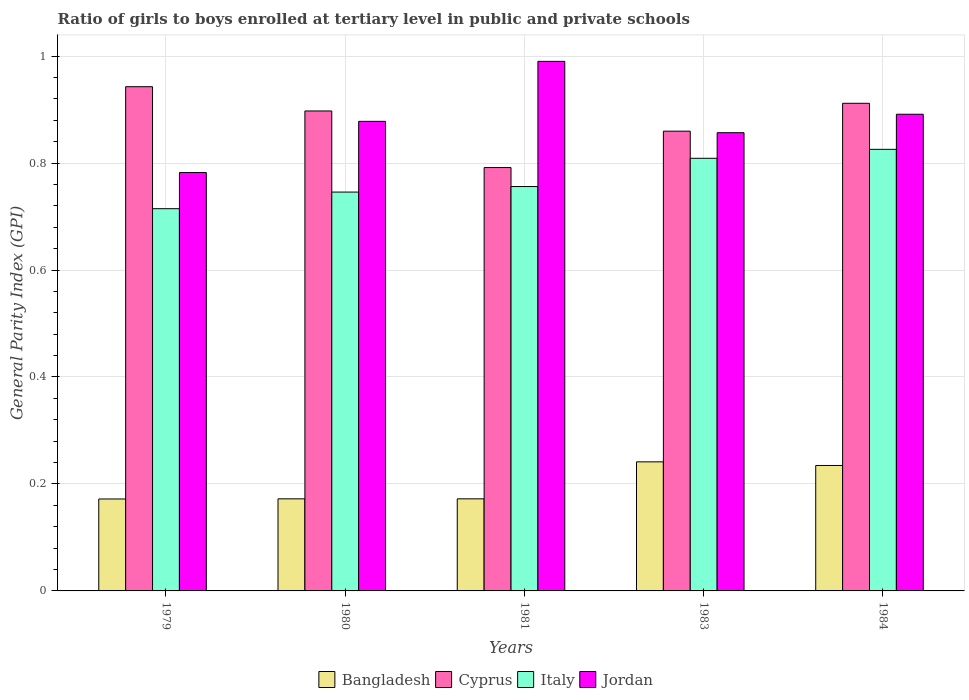Are the number of bars per tick equal to the number of legend labels?
Make the answer very short. Yes. Are the number of bars on each tick of the X-axis equal?
Provide a succinct answer. Yes. How many bars are there on the 5th tick from the left?
Provide a succinct answer. 4. How many bars are there on the 3rd tick from the right?
Your answer should be compact. 4. What is the label of the 2nd group of bars from the left?
Keep it short and to the point. 1980. In how many cases, is the number of bars for a given year not equal to the number of legend labels?
Ensure brevity in your answer.  0. What is the general parity index in Bangladesh in 1983?
Offer a very short reply. 0.24. Across all years, what is the minimum general parity index in Italy?
Provide a succinct answer. 0.71. In which year was the general parity index in Cyprus maximum?
Keep it short and to the point. 1979. What is the total general parity index in Bangladesh in the graph?
Provide a short and direct response. 0.99. What is the difference between the general parity index in Cyprus in 1981 and that in 1983?
Your answer should be compact. -0.07. What is the difference between the general parity index in Italy in 1981 and the general parity index in Jordan in 1983?
Your answer should be very brief. -0.1. What is the average general parity index in Italy per year?
Make the answer very short. 0.77. In the year 1983, what is the difference between the general parity index in Cyprus and general parity index in Bangladesh?
Make the answer very short. 0.62. What is the ratio of the general parity index in Italy in 1979 to that in 1980?
Your answer should be very brief. 0.96. What is the difference between the highest and the second highest general parity index in Jordan?
Make the answer very short. 0.1. What is the difference between the highest and the lowest general parity index in Italy?
Your response must be concise. 0.11. In how many years, is the general parity index in Cyprus greater than the average general parity index in Cyprus taken over all years?
Ensure brevity in your answer.  3. Is the sum of the general parity index in Cyprus in 1980 and 1981 greater than the maximum general parity index in Italy across all years?
Your answer should be compact. Yes. What does the 2nd bar from the left in 1981 represents?
Your answer should be very brief. Cyprus. What does the 1st bar from the right in 1980 represents?
Ensure brevity in your answer.  Jordan. Is it the case that in every year, the sum of the general parity index in Italy and general parity index in Cyprus is greater than the general parity index in Bangladesh?
Provide a short and direct response. Yes. Are all the bars in the graph horizontal?
Your answer should be compact. No. How many years are there in the graph?
Offer a very short reply. 5. Does the graph contain any zero values?
Offer a terse response. No. How many legend labels are there?
Give a very brief answer. 4. How are the legend labels stacked?
Your response must be concise. Horizontal. What is the title of the graph?
Your answer should be compact. Ratio of girls to boys enrolled at tertiary level in public and private schools. What is the label or title of the X-axis?
Ensure brevity in your answer.  Years. What is the label or title of the Y-axis?
Make the answer very short. General Parity Index (GPI). What is the General Parity Index (GPI) of Bangladesh in 1979?
Make the answer very short. 0.17. What is the General Parity Index (GPI) in Cyprus in 1979?
Keep it short and to the point. 0.94. What is the General Parity Index (GPI) of Italy in 1979?
Provide a short and direct response. 0.71. What is the General Parity Index (GPI) of Jordan in 1979?
Offer a very short reply. 0.78. What is the General Parity Index (GPI) of Bangladesh in 1980?
Your answer should be compact. 0.17. What is the General Parity Index (GPI) in Cyprus in 1980?
Offer a very short reply. 0.9. What is the General Parity Index (GPI) in Italy in 1980?
Your answer should be very brief. 0.75. What is the General Parity Index (GPI) in Jordan in 1980?
Offer a very short reply. 0.88. What is the General Parity Index (GPI) in Bangladesh in 1981?
Your answer should be very brief. 0.17. What is the General Parity Index (GPI) in Cyprus in 1981?
Make the answer very short. 0.79. What is the General Parity Index (GPI) of Italy in 1981?
Provide a succinct answer. 0.76. What is the General Parity Index (GPI) of Bangladesh in 1983?
Keep it short and to the point. 0.24. What is the General Parity Index (GPI) of Cyprus in 1983?
Offer a very short reply. 0.86. What is the General Parity Index (GPI) of Italy in 1983?
Give a very brief answer. 0.81. What is the General Parity Index (GPI) in Jordan in 1983?
Ensure brevity in your answer.  0.86. What is the General Parity Index (GPI) of Bangladesh in 1984?
Your answer should be compact. 0.23. What is the General Parity Index (GPI) in Cyprus in 1984?
Your answer should be very brief. 0.91. What is the General Parity Index (GPI) in Italy in 1984?
Ensure brevity in your answer.  0.83. What is the General Parity Index (GPI) of Jordan in 1984?
Give a very brief answer. 0.89. Across all years, what is the maximum General Parity Index (GPI) in Bangladesh?
Make the answer very short. 0.24. Across all years, what is the maximum General Parity Index (GPI) of Cyprus?
Make the answer very short. 0.94. Across all years, what is the maximum General Parity Index (GPI) of Italy?
Keep it short and to the point. 0.83. Across all years, what is the maximum General Parity Index (GPI) of Jordan?
Your response must be concise. 0.99. Across all years, what is the minimum General Parity Index (GPI) of Bangladesh?
Give a very brief answer. 0.17. Across all years, what is the minimum General Parity Index (GPI) in Cyprus?
Give a very brief answer. 0.79. Across all years, what is the minimum General Parity Index (GPI) of Italy?
Your answer should be very brief. 0.71. Across all years, what is the minimum General Parity Index (GPI) in Jordan?
Your answer should be very brief. 0.78. What is the total General Parity Index (GPI) of Bangladesh in the graph?
Make the answer very short. 0.99. What is the total General Parity Index (GPI) in Cyprus in the graph?
Ensure brevity in your answer.  4.4. What is the total General Parity Index (GPI) in Italy in the graph?
Provide a short and direct response. 3.85. What is the total General Parity Index (GPI) of Jordan in the graph?
Make the answer very short. 4.4. What is the difference between the General Parity Index (GPI) of Bangladesh in 1979 and that in 1980?
Offer a terse response. -0. What is the difference between the General Parity Index (GPI) in Cyprus in 1979 and that in 1980?
Your response must be concise. 0.05. What is the difference between the General Parity Index (GPI) in Italy in 1979 and that in 1980?
Your answer should be very brief. -0.03. What is the difference between the General Parity Index (GPI) of Jordan in 1979 and that in 1980?
Provide a short and direct response. -0.1. What is the difference between the General Parity Index (GPI) of Bangladesh in 1979 and that in 1981?
Offer a terse response. -0. What is the difference between the General Parity Index (GPI) in Cyprus in 1979 and that in 1981?
Ensure brevity in your answer.  0.15. What is the difference between the General Parity Index (GPI) in Italy in 1979 and that in 1981?
Give a very brief answer. -0.04. What is the difference between the General Parity Index (GPI) of Jordan in 1979 and that in 1981?
Offer a very short reply. -0.21. What is the difference between the General Parity Index (GPI) of Bangladesh in 1979 and that in 1983?
Provide a succinct answer. -0.07. What is the difference between the General Parity Index (GPI) in Cyprus in 1979 and that in 1983?
Offer a very short reply. 0.08. What is the difference between the General Parity Index (GPI) in Italy in 1979 and that in 1983?
Your response must be concise. -0.09. What is the difference between the General Parity Index (GPI) in Jordan in 1979 and that in 1983?
Keep it short and to the point. -0.07. What is the difference between the General Parity Index (GPI) in Bangladesh in 1979 and that in 1984?
Your answer should be very brief. -0.06. What is the difference between the General Parity Index (GPI) in Cyprus in 1979 and that in 1984?
Your answer should be compact. 0.03. What is the difference between the General Parity Index (GPI) in Italy in 1979 and that in 1984?
Your answer should be compact. -0.11. What is the difference between the General Parity Index (GPI) in Jordan in 1979 and that in 1984?
Your response must be concise. -0.11. What is the difference between the General Parity Index (GPI) of Cyprus in 1980 and that in 1981?
Your answer should be very brief. 0.11. What is the difference between the General Parity Index (GPI) in Italy in 1980 and that in 1981?
Make the answer very short. -0.01. What is the difference between the General Parity Index (GPI) of Jordan in 1980 and that in 1981?
Ensure brevity in your answer.  -0.11. What is the difference between the General Parity Index (GPI) in Bangladesh in 1980 and that in 1983?
Your response must be concise. -0.07. What is the difference between the General Parity Index (GPI) of Cyprus in 1980 and that in 1983?
Your response must be concise. 0.04. What is the difference between the General Parity Index (GPI) of Italy in 1980 and that in 1983?
Offer a very short reply. -0.06. What is the difference between the General Parity Index (GPI) of Jordan in 1980 and that in 1983?
Provide a short and direct response. 0.02. What is the difference between the General Parity Index (GPI) of Bangladesh in 1980 and that in 1984?
Your response must be concise. -0.06. What is the difference between the General Parity Index (GPI) of Cyprus in 1980 and that in 1984?
Offer a terse response. -0.01. What is the difference between the General Parity Index (GPI) in Italy in 1980 and that in 1984?
Offer a terse response. -0.08. What is the difference between the General Parity Index (GPI) in Jordan in 1980 and that in 1984?
Offer a terse response. -0.01. What is the difference between the General Parity Index (GPI) of Bangladesh in 1981 and that in 1983?
Your answer should be very brief. -0.07. What is the difference between the General Parity Index (GPI) of Cyprus in 1981 and that in 1983?
Offer a very short reply. -0.07. What is the difference between the General Parity Index (GPI) in Italy in 1981 and that in 1983?
Provide a short and direct response. -0.05. What is the difference between the General Parity Index (GPI) of Jordan in 1981 and that in 1983?
Keep it short and to the point. 0.13. What is the difference between the General Parity Index (GPI) in Bangladesh in 1981 and that in 1984?
Offer a very short reply. -0.06. What is the difference between the General Parity Index (GPI) of Cyprus in 1981 and that in 1984?
Provide a short and direct response. -0.12. What is the difference between the General Parity Index (GPI) in Italy in 1981 and that in 1984?
Ensure brevity in your answer.  -0.07. What is the difference between the General Parity Index (GPI) in Jordan in 1981 and that in 1984?
Your answer should be very brief. 0.1. What is the difference between the General Parity Index (GPI) in Bangladesh in 1983 and that in 1984?
Your answer should be compact. 0.01. What is the difference between the General Parity Index (GPI) in Cyprus in 1983 and that in 1984?
Provide a short and direct response. -0.05. What is the difference between the General Parity Index (GPI) of Italy in 1983 and that in 1984?
Offer a terse response. -0.02. What is the difference between the General Parity Index (GPI) of Jordan in 1983 and that in 1984?
Keep it short and to the point. -0.03. What is the difference between the General Parity Index (GPI) in Bangladesh in 1979 and the General Parity Index (GPI) in Cyprus in 1980?
Make the answer very short. -0.73. What is the difference between the General Parity Index (GPI) of Bangladesh in 1979 and the General Parity Index (GPI) of Italy in 1980?
Provide a short and direct response. -0.57. What is the difference between the General Parity Index (GPI) of Bangladesh in 1979 and the General Parity Index (GPI) of Jordan in 1980?
Make the answer very short. -0.71. What is the difference between the General Parity Index (GPI) in Cyprus in 1979 and the General Parity Index (GPI) in Italy in 1980?
Offer a very short reply. 0.2. What is the difference between the General Parity Index (GPI) of Cyprus in 1979 and the General Parity Index (GPI) of Jordan in 1980?
Keep it short and to the point. 0.06. What is the difference between the General Parity Index (GPI) of Italy in 1979 and the General Parity Index (GPI) of Jordan in 1980?
Give a very brief answer. -0.16. What is the difference between the General Parity Index (GPI) in Bangladesh in 1979 and the General Parity Index (GPI) in Cyprus in 1981?
Offer a terse response. -0.62. What is the difference between the General Parity Index (GPI) in Bangladesh in 1979 and the General Parity Index (GPI) in Italy in 1981?
Ensure brevity in your answer.  -0.58. What is the difference between the General Parity Index (GPI) in Bangladesh in 1979 and the General Parity Index (GPI) in Jordan in 1981?
Make the answer very short. -0.82. What is the difference between the General Parity Index (GPI) in Cyprus in 1979 and the General Parity Index (GPI) in Italy in 1981?
Keep it short and to the point. 0.19. What is the difference between the General Parity Index (GPI) in Cyprus in 1979 and the General Parity Index (GPI) in Jordan in 1981?
Give a very brief answer. -0.05. What is the difference between the General Parity Index (GPI) of Italy in 1979 and the General Parity Index (GPI) of Jordan in 1981?
Ensure brevity in your answer.  -0.28. What is the difference between the General Parity Index (GPI) in Bangladesh in 1979 and the General Parity Index (GPI) in Cyprus in 1983?
Your response must be concise. -0.69. What is the difference between the General Parity Index (GPI) in Bangladesh in 1979 and the General Parity Index (GPI) in Italy in 1983?
Make the answer very short. -0.64. What is the difference between the General Parity Index (GPI) in Bangladesh in 1979 and the General Parity Index (GPI) in Jordan in 1983?
Make the answer very short. -0.68. What is the difference between the General Parity Index (GPI) in Cyprus in 1979 and the General Parity Index (GPI) in Italy in 1983?
Your answer should be very brief. 0.13. What is the difference between the General Parity Index (GPI) of Cyprus in 1979 and the General Parity Index (GPI) of Jordan in 1983?
Your response must be concise. 0.09. What is the difference between the General Parity Index (GPI) of Italy in 1979 and the General Parity Index (GPI) of Jordan in 1983?
Make the answer very short. -0.14. What is the difference between the General Parity Index (GPI) of Bangladesh in 1979 and the General Parity Index (GPI) of Cyprus in 1984?
Your answer should be very brief. -0.74. What is the difference between the General Parity Index (GPI) in Bangladesh in 1979 and the General Parity Index (GPI) in Italy in 1984?
Your response must be concise. -0.65. What is the difference between the General Parity Index (GPI) in Bangladesh in 1979 and the General Parity Index (GPI) in Jordan in 1984?
Provide a succinct answer. -0.72. What is the difference between the General Parity Index (GPI) of Cyprus in 1979 and the General Parity Index (GPI) of Italy in 1984?
Provide a short and direct response. 0.12. What is the difference between the General Parity Index (GPI) in Cyprus in 1979 and the General Parity Index (GPI) in Jordan in 1984?
Provide a succinct answer. 0.05. What is the difference between the General Parity Index (GPI) of Italy in 1979 and the General Parity Index (GPI) of Jordan in 1984?
Keep it short and to the point. -0.18. What is the difference between the General Parity Index (GPI) of Bangladesh in 1980 and the General Parity Index (GPI) of Cyprus in 1981?
Offer a very short reply. -0.62. What is the difference between the General Parity Index (GPI) of Bangladesh in 1980 and the General Parity Index (GPI) of Italy in 1981?
Give a very brief answer. -0.58. What is the difference between the General Parity Index (GPI) of Bangladesh in 1980 and the General Parity Index (GPI) of Jordan in 1981?
Keep it short and to the point. -0.82. What is the difference between the General Parity Index (GPI) of Cyprus in 1980 and the General Parity Index (GPI) of Italy in 1981?
Your answer should be very brief. 0.14. What is the difference between the General Parity Index (GPI) of Cyprus in 1980 and the General Parity Index (GPI) of Jordan in 1981?
Provide a succinct answer. -0.09. What is the difference between the General Parity Index (GPI) of Italy in 1980 and the General Parity Index (GPI) of Jordan in 1981?
Offer a very short reply. -0.24. What is the difference between the General Parity Index (GPI) of Bangladesh in 1980 and the General Parity Index (GPI) of Cyprus in 1983?
Provide a succinct answer. -0.69. What is the difference between the General Parity Index (GPI) in Bangladesh in 1980 and the General Parity Index (GPI) in Italy in 1983?
Provide a succinct answer. -0.64. What is the difference between the General Parity Index (GPI) of Bangladesh in 1980 and the General Parity Index (GPI) of Jordan in 1983?
Make the answer very short. -0.68. What is the difference between the General Parity Index (GPI) of Cyprus in 1980 and the General Parity Index (GPI) of Italy in 1983?
Provide a succinct answer. 0.09. What is the difference between the General Parity Index (GPI) of Cyprus in 1980 and the General Parity Index (GPI) of Jordan in 1983?
Keep it short and to the point. 0.04. What is the difference between the General Parity Index (GPI) in Italy in 1980 and the General Parity Index (GPI) in Jordan in 1983?
Ensure brevity in your answer.  -0.11. What is the difference between the General Parity Index (GPI) in Bangladesh in 1980 and the General Parity Index (GPI) in Cyprus in 1984?
Make the answer very short. -0.74. What is the difference between the General Parity Index (GPI) of Bangladesh in 1980 and the General Parity Index (GPI) of Italy in 1984?
Your response must be concise. -0.65. What is the difference between the General Parity Index (GPI) in Bangladesh in 1980 and the General Parity Index (GPI) in Jordan in 1984?
Provide a short and direct response. -0.72. What is the difference between the General Parity Index (GPI) of Cyprus in 1980 and the General Parity Index (GPI) of Italy in 1984?
Your response must be concise. 0.07. What is the difference between the General Parity Index (GPI) in Cyprus in 1980 and the General Parity Index (GPI) in Jordan in 1984?
Provide a succinct answer. 0.01. What is the difference between the General Parity Index (GPI) of Italy in 1980 and the General Parity Index (GPI) of Jordan in 1984?
Your answer should be very brief. -0.15. What is the difference between the General Parity Index (GPI) in Bangladesh in 1981 and the General Parity Index (GPI) in Cyprus in 1983?
Your answer should be very brief. -0.69. What is the difference between the General Parity Index (GPI) in Bangladesh in 1981 and the General Parity Index (GPI) in Italy in 1983?
Keep it short and to the point. -0.64. What is the difference between the General Parity Index (GPI) in Bangladesh in 1981 and the General Parity Index (GPI) in Jordan in 1983?
Provide a succinct answer. -0.68. What is the difference between the General Parity Index (GPI) of Cyprus in 1981 and the General Parity Index (GPI) of Italy in 1983?
Your answer should be compact. -0.02. What is the difference between the General Parity Index (GPI) in Cyprus in 1981 and the General Parity Index (GPI) in Jordan in 1983?
Your answer should be compact. -0.07. What is the difference between the General Parity Index (GPI) of Italy in 1981 and the General Parity Index (GPI) of Jordan in 1983?
Your answer should be compact. -0.1. What is the difference between the General Parity Index (GPI) in Bangladesh in 1981 and the General Parity Index (GPI) in Cyprus in 1984?
Give a very brief answer. -0.74. What is the difference between the General Parity Index (GPI) in Bangladesh in 1981 and the General Parity Index (GPI) in Italy in 1984?
Your response must be concise. -0.65. What is the difference between the General Parity Index (GPI) in Bangladesh in 1981 and the General Parity Index (GPI) in Jordan in 1984?
Ensure brevity in your answer.  -0.72. What is the difference between the General Parity Index (GPI) in Cyprus in 1981 and the General Parity Index (GPI) in Italy in 1984?
Offer a terse response. -0.03. What is the difference between the General Parity Index (GPI) of Cyprus in 1981 and the General Parity Index (GPI) of Jordan in 1984?
Your answer should be very brief. -0.1. What is the difference between the General Parity Index (GPI) in Italy in 1981 and the General Parity Index (GPI) in Jordan in 1984?
Provide a succinct answer. -0.14. What is the difference between the General Parity Index (GPI) of Bangladesh in 1983 and the General Parity Index (GPI) of Cyprus in 1984?
Offer a very short reply. -0.67. What is the difference between the General Parity Index (GPI) in Bangladesh in 1983 and the General Parity Index (GPI) in Italy in 1984?
Offer a very short reply. -0.58. What is the difference between the General Parity Index (GPI) in Bangladesh in 1983 and the General Parity Index (GPI) in Jordan in 1984?
Ensure brevity in your answer.  -0.65. What is the difference between the General Parity Index (GPI) in Cyprus in 1983 and the General Parity Index (GPI) in Italy in 1984?
Ensure brevity in your answer.  0.03. What is the difference between the General Parity Index (GPI) in Cyprus in 1983 and the General Parity Index (GPI) in Jordan in 1984?
Make the answer very short. -0.03. What is the difference between the General Parity Index (GPI) in Italy in 1983 and the General Parity Index (GPI) in Jordan in 1984?
Your answer should be very brief. -0.08. What is the average General Parity Index (GPI) in Bangladesh per year?
Offer a terse response. 0.2. What is the average General Parity Index (GPI) of Cyprus per year?
Make the answer very short. 0.88. What is the average General Parity Index (GPI) of Italy per year?
Make the answer very short. 0.77. What is the average General Parity Index (GPI) in Jordan per year?
Keep it short and to the point. 0.88. In the year 1979, what is the difference between the General Parity Index (GPI) in Bangladesh and General Parity Index (GPI) in Cyprus?
Keep it short and to the point. -0.77. In the year 1979, what is the difference between the General Parity Index (GPI) in Bangladesh and General Parity Index (GPI) in Italy?
Ensure brevity in your answer.  -0.54. In the year 1979, what is the difference between the General Parity Index (GPI) in Bangladesh and General Parity Index (GPI) in Jordan?
Provide a succinct answer. -0.61. In the year 1979, what is the difference between the General Parity Index (GPI) in Cyprus and General Parity Index (GPI) in Italy?
Your answer should be compact. 0.23. In the year 1979, what is the difference between the General Parity Index (GPI) in Cyprus and General Parity Index (GPI) in Jordan?
Your answer should be compact. 0.16. In the year 1979, what is the difference between the General Parity Index (GPI) in Italy and General Parity Index (GPI) in Jordan?
Offer a terse response. -0.07. In the year 1980, what is the difference between the General Parity Index (GPI) of Bangladesh and General Parity Index (GPI) of Cyprus?
Keep it short and to the point. -0.73. In the year 1980, what is the difference between the General Parity Index (GPI) of Bangladesh and General Parity Index (GPI) of Italy?
Offer a terse response. -0.57. In the year 1980, what is the difference between the General Parity Index (GPI) in Bangladesh and General Parity Index (GPI) in Jordan?
Your response must be concise. -0.71. In the year 1980, what is the difference between the General Parity Index (GPI) of Cyprus and General Parity Index (GPI) of Italy?
Make the answer very short. 0.15. In the year 1980, what is the difference between the General Parity Index (GPI) in Cyprus and General Parity Index (GPI) in Jordan?
Make the answer very short. 0.02. In the year 1980, what is the difference between the General Parity Index (GPI) of Italy and General Parity Index (GPI) of Jordan?
Ensure brevity in your answer.  -0.13. In the year 1981, what is the difference between the General Parity Index (GPI) of Bangladesh and General Parity Index (GPI) of Cyprus?
Provide a succinct answer. -0.62. In the year 1981, what is the difference between the General Parity Index (GPI) of Bangladesh and General Parity Index (GPI) of Italy?
Offer a very short reply. -0.58. In the year 1981, what is the difference between the General Parity Index (GPI) in Bangladesh and General Parity Index (GPI) in Jordan?
Offer a very short reply. -0.82. In the year 1981, what is the difference between the General Parity Index (GPI) of Cyprus and General Parity Index (GPI) of Italy?
Provide a succinct answer. 0.04. In the year 1981, what is the difference between the General Parity Index (GPI) of Cyprus and General Parity Index (GPI) of Jordan?
Your answer should be very brief. -0.2. In the year 1981, what is the difference between the General Parity Index (GPI) of Italy and General Parity Index (GPI) of Jordan?
Ensure brevity in your answer.  -0.23. In the year 1983, what is the difference between the General Parity Index (GPI) of Bangladesh and General Parity Index (GPI) of Cyprus?
Make the answer very short. -0.62. In the year 1983, what is the difference between the General Parity Index (GPI) of Bangladesh and General Parity Index (GPI) of Italy?
Offer a very short reply. -0.57. In the year 1983, what is the difference between the General Parity Index (GPI) in Bangladesh and General Parity Index (GPI) in Jordan?
Provide a succinct answer. -0.62. In the year 1983, what is the difference between the General Parity Index (GPI) in Cyprus and General Parity Index (GPI) in Italy?
Provide a succinct answer. 0.05. In the year 1983, what is the difference between the General Parity Index (GPI) of Cyprus and General Parity Index (GPI) of Jordan?
Offer a very short reply. 0. In the year 1983, what is the difference between the General Parity Index (GPI) of Italy and General Parity Index (GPI) of Jordan?
Provide a succinct answer. -0.05. In the year 1984, what is the difference between the General Parity Index (GPI) in Bangladesh and General Parity Index (GPI) in Cyprus?
Keep it short and to the point. -0.68. In the year 1984, what is the difference between the General Parity Index (GPI) of Bangladesh and General Parity Index (GPI) of Italy?
Your answer should be very brief. -0.59. In the year 1984, what is the difference between the General Parity Index (GPI) of Bangladesh and General Parity Index (GPI) of Jordan?
Your answer should be compact. -0.66. In the year 1984, what is the difference between the General Parity Index (GPI) of Cyprus and General Parity Index (GPI) of Italy?
Your answer should be compact. 0.09. In the year 1984, what is the difference between the General Parity Index (GPI) in Cyprus and General Parity Index (GPI) in Jordan?
Offer a very short reply. 0.02. In the year 1984, what is the difference between the General Parity Index (GPI) in Italy and General Parity Index (GPI) in Jordan?
Provide a succinct answer. -0.07. What is the ratio of the General Parity Index (GPI) of Bangladesh in 1979 to that in 1980?
Your response must be concise. 1. What is the ratio of the General Parity Index (GPI) of Cyprus in 1979 to that in 1980?
Offer a very short reply. 1.05. What is the ratio of the General Parity Index (GPI) of Jordan in 1979 to that in 1980?
Give a very brief answer. 0.89. What is the ratio of the General Parity Index (GPI) in Bangladesh in 1979 to that in 1981?
Provide a succinct answer. 1. What is the ratio of the General Parity Index (GPI) in Cyprus in 1979 to that in 1981?
Offer a very short reply. 1.19. What is the ratio of the General Parity Index (GPI) in Italy in 1979 to that in 1981?
Give a very brief answer. 0.95. What is the ratio of the General Parity Index (GPI) of Jordan in 1979 to that in 1981?
Make the answer very short. 0.79. What is the ratio of the General Parity Index (GPI) in Bangladesh in 1979 to that in 1983?
Ensure brevity in your answer.  0.71. What is the ratio of the General Parity Index (GPI) in Cyprus in 1979 to that in 1983?
Keep it short and to the point. 1.1. What is the ratio of the General Parity Index (GPI) of Italy in 1979 to that in 1983?
Make the answer very short. 0.88. What is the ratio of the General Parity Index (GPI) in Bangladesh in 1979 to that in 1984?
Keep it short and to the point. 0.73. What is the ratio of the General Parity Index (GPI) of Cyprus in 1979 to that in 1984?
Ensure brevity in your answer.  1.03. What is the ratio of the General Parity Index (GPI) in Italy in 1979 to that in 1984?
Provide a short and direct response. 0.87. What is the ratio of the General Parity Index (GPI) in Jordan in 1979 to that in 1984?
Provide a short and direct response. 0.88. What is the ratio of the General Parity Index (GPI) in Cyprus in 1980 to that in 1981?
Make the answer very short. 1.13. What is the ratio of the General Parity Index (GPI) of Italy in 1980 to that in 1981?
Keep it short and to the point. 0.99. What is the ratio of the General Parity Index (GPI) in Jordan in 1980 to that in 1981?
Keep it short and to the point. 0.89. What is the ratio of the General Parity Index (GPI) in Bangladesh in 1980 to that in 1983?
Your answer should be very brief. 0.71. What is the ratio of the General Parity Index (GPI) in Cyprus in 1980 to that in 1983?
Make the answer very short. 1.04. What is the ratio of the General Parity Index (GPI) in Italy in 1980 to that in 1983?
Offer a terse response. 0.92. What is the ratio of the General Parity Index (GPI) in Jordan in 1980 to that in 1983?
Your answer should be very brief. 1.02. What is the ratio of the General Parity Index (GPI) of Bangladesh in 1980 to that in 1984?
Keep it short and to the point. 0.73. What is the ratio of the General Parity Index (GPI) of Cyprus in 1980 to that in 1984?
Keep it short and to the point. 0.98. What is the ratio of the General Parity Index (GPI) in Italy in 1980 to that in 1984?
Your answer should be very brief. 0.9. What is the ratio of the General Parity Index (GPI) in Jordan in 1980 to that in 1984?
Provide a short and direct response. 0.99. What is the ratio of the General Parity Index (GPI) in Bangladesh in 1981 to that in 1983?
Keep it short and to the point. 0.71. What is the ratio of the General Parity Index (GPI) of Cyprus in 1981 to that in 1983?
Offer a very short reply. 0.92. What is the ratio of the General Parity Index (GPI) in Italy in 1981 to that in 1983?
Your answer should be compact. 0.93. What is the ratio of the General Parity Index (GPI) of Jordan in 1981 to that in 1983?
Offer a very short reply. 1.16. What is the ratio of the General Parity Index (GPI) of Bangladesh in 1981 to that in 1984?
Your answer should be compact. 0.73. What is the ratio of the General Parity Index (GPI) in Cyprus in 1981 to that in 1984?
Give a very brief answer. 0.87. What is the ratio of the General Parity Index (GPI) of Italy in 1981 to that in 1984?
Provide a short and direct response. 0.92. What is the ratio of the General Parity Index (GPI) in Jordan in 1981 to that in 1984?
Ensure brevity in your answer.  1.11. What is the ratio of the General Parity Index (GPI) of Bangladesh in 1983 to that in 1984?
Provide a succinct answer. 1.03. What is the ratio of the General Parity Index (GPI) of Cyprus in 1983 to that in 1984?
Your response must be concise. 0.94. What is the ratio of the General Parity Index (GPI) in Italy in 1983 to that in 1984?
Provide a succinct answer. 0.98. What is the ratio of the General Parity Index (GPI) of Jordan in 1983 to that in 1984?
Offer a very short reply. 0.96. What is the difference between the highest and the second highest General Parity Index (GPI) of Bangladesh?
Your answer should be very brief. 0.01. What is the difference between the highest and the second highest General Parity Index (GPI) of Cyprus?
Provide a succinct answer. 0.03. What is the difference between the highest and the second highest General Parity Index (GPI) of Italy?
Keep it short and to the point. 0.02. What is the difference between the highest and the second highest General Parity Index (GPI) of Jordan?
Your response must be concise. 0.1. What is the difference between the highest and the lowest General Parity Index (GPI) of Bangladesh?
Provide a succinct answer. 0.07. What is the difference between the highest and the lowest General Parity Index (GPI) of Cyprus?
Keep it short and to the point. 0.15. What is the difference between the highest and the lowest General Parity Index (GPI) in Italy?
Give a very brief answer. 0.11. What is the difference between the highest and the lowest General Parity Index (GPI) in Jordan?
Ensure brevity in your answer.  0.21. 